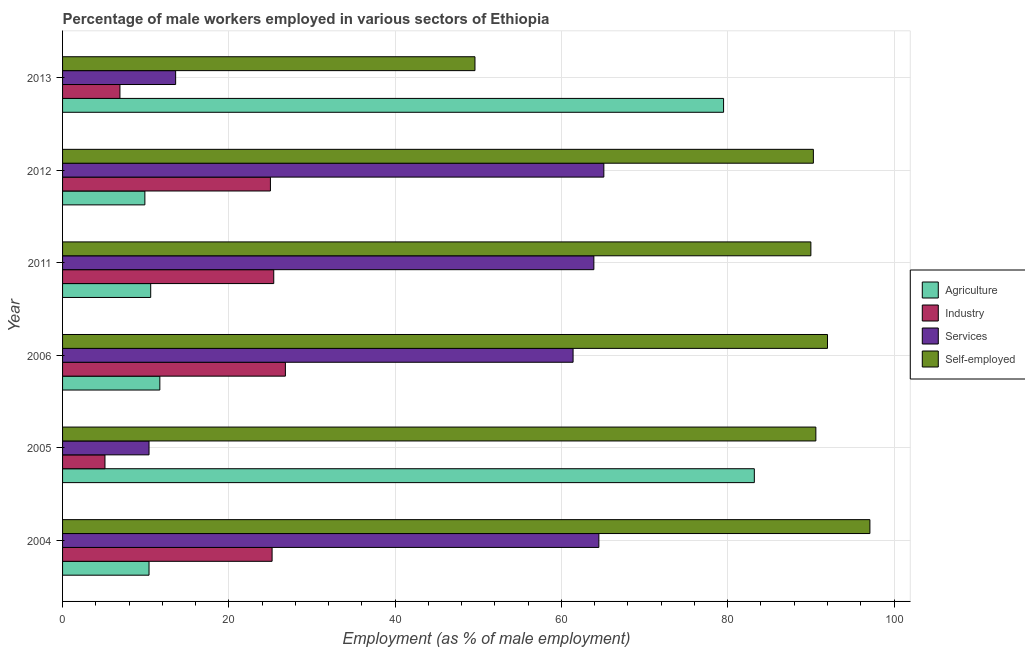How many different coloured bars are there?
Give a very brief answer. 4. Are the number of bars per tick equal to the number of legend labels?
Make the answer very short. Yes. Are the number of bars on each tick of the Y-axis equal?
Your answer should be very brief. Yes. How many bars are there on the 4th tick from the top?
Provide a short and direct response. 4. What is the label of the 1st group of bars from the top?
Keep it short and to the point. 2013. What is the percentage of male workers in services in 2013?
Make the answer very short. 13.6. Across all years, what is the maximum percentage of male workers in services?
Offer a very short reply. 65.1. Across all years, what is the minimum percentage of self employed male workers?
Offer a very short reply. 49.6. What is the total percentage of male workers in industry in the graph?
Give a very brief answer. 114.4. What is the difference between the percentage of male workers in services in 2005 and that in 2011?
Offer a very short reply. -53.5. What is the difference between the percentage of self employed male workers in 2013 and the percentage of male workers in agriculture in 2006?
Your response must be concise. 37.9. What is the average percentage of male workers in services per year?
Your answer should be compact. 46.48. In the year 2005, what is the difference between the percentage of male workers in industry and percentage of male workers in services?
Ensure brevity in your answer.  -5.3. In how many years, is the percentage of self employed male workers greater than 32 %?
Provide a succinct answer. 6. What is the ratio of the percentage of self employed male workers in 2004 to that in 2006?
Provide a short and direct response. 1.05. Is the percentage of self employed male workers in 2004 less than that in 2013?
Give a very brief answer. No. What is the difference between the highest and the second highest percentage of male workers in industry?
Make the answer very short. 1.4. What is the difference between the highest and the lowest percentage of self employed male workers?
Your answer should be very brief. 47.5. In how many years, is the percentage of self employed male workers greater than the average percentage of self employed male workers taken over all years?
Keep it short and to the point. 5. Is it the case that in every year, the sum of the percentage of self employed male workers and percentage of male workers in industry is greater than the sum of percentage of male workers in services and percentage of male workers in agriculture?
Provide a short and direct response. No. What does the 3rd bar from the top in 2005 represents?
Your response must be concise. Industry. What does the 1st bar from the bottom in 2012 represents?
Your response must be concise. Agriculture. How many years are there in the graph?
Make the answer very short. 6. What is the difference between two consecutive major ticks on the X-axis?
Provide a succinct answer. 20. How many legend labels are there?
Provide a succinct answer. 4. How are the legend labels stacked?
Ensure brevity in your answer.  Vertical. What is the title of the graph?
Give a very brief answer. Percentage of male workers employed in various sectors of Ethiopia. What is the label or title of the X-axis?
Give a very brief answer. Employment (as % of male employment). What is the label or title of the Y-axis?
Your answer should be very brief. Year. What is the Employment (as % of male employment) of Agriculture in 2004?
Keep it short and to the point. 10.4. What is the Employment (as % of male employment) of Industry in 2004?
Offer a terse response. 25.2. What is the Employment (as % of male employment) of Services in 2004?
Your answer should be very brief. 64.5. What is the Employment (as % of male employment) in Self-employed in 2004?
Provide a short and direct response. 97.1. What is the Employment (as % of male employment) in Agriculture in 2005?
Provide a short and direct response. 83.2. What is the Employment (as % of male employment) in Industry in 2005?
Your answer should be very brief. 5.1. What is the Employment (as % of male employment) of Services in 2005?
Provide a succinct answer. 10.4. What is the Employment (as % of male employment) of Self-employed in 2005?
Your response must be concise. 90.6. What is the Employment (as % of male employment) of Agriculture in 2006?
Make the answer very short. 11.7. What is the Employment (as % of male employment) in Industry in 2006?
Your answer should be compact. 26.8. What is the Employment (as % of male employment) in Services in 2006?
Keep it short and to the point. 61.4. What is the Employment (as % of male employment) in Self-employed in 2006?
Provide a succinct answer. 92. What is the Employment (as % of male employment) in Agriculture in 2011?
Offer a terse response. 10.6. What is the Employment (as % of male employment) in Industry in 2011?
Provide a succinct answer. 25.4. What is the Employment (as % of male employment) in Services in 2011?
Make the answer very short. 63.9. What is the Employment (as % of male employment) in Agriculture in 2012?
Offer a very short reply. 9.9. What is the Employment (as % of male employment) in Services in 2012?
Provide a succinct answer. 65.1. What is the Employment (as % of male employment) of Self-employed in 2012?
Offer a terse response. 90.3. What is the Employment (as % of male employment) in Agriculture in 2013?
Offer a terse response. 79.5. What is the Employment (as % of male employment) of Industry in 2013?
Provide a short and direct response. 6.9. What is the Employment (as % of male employment) in Services in 2013?
Give a very brief answer. 13.6. What is the Employment (as % of male employment) in Self-employed in 2013?
Keep it short and to the point. 49.6. Across all years, what is the maximum Employment (as % of male employment) in Agriculture?
Give a very brief answer. 83.2. Across all years, what is the maximum Employment (as % of male employment) in Industry?
Your answer should be compact. 26.8. Across all years, what is the maximum Employment (as % of male employment) of Services?
Offer a terse response. 65.1. Across all years, what is the maximum Employment (as % of male employment) of Self-employed?
Provide a short and direct response. 97.1. Across all years, what is the minimum Employment (as % of male employment) in Agriculture?
Give a very brief answer. 9.9. Across all years, what is the minimum Employment (as % of male employment) of Industry?
Give a very brief answer. 5.1. Across all years, what is the minimum Employment (as % of male employment) in Services?
Keep it short and to the point. 10.4. Across all years, what is the minimum Employment (as % of male employment) of Self-employed?
Provide a succinct answer. 49.6. What is the total Employment (as % of male employment) in Agriculture in the graph?
Give a very brief answer. 205.3. What is the total Employment (as % of male employment) in Industry in the graph?
Your response must be concise. 114.4. What is the total Employment (as % of male employment) of Services in the graph?
Provide a succinct answer. 278.9. What is the total Employment (as % of male employment) in Self-employed in the graph?
Offer a terse response. 509.6. What is the difference between the Employment (as % of male employment) of Agriculture in 2004 and that in 2005?
Give a very brief answer. -72.8. What is the difference between the Employment (as % of male employment) of Industry in 2004 and that in 2005?
Your response must be concise. 20.1. What is the difference between the Employment (as % of male employment) of Services in 2004 and that in 2005?
Your answer should be very brief. 54.1. What is the difference between the Employment (as % of male employment) of Industry in 2004 and that in 2006?
Offer a terse response. -1.6. What is the difference between the Employment (as % of male employment) of Services in 2004 and that in 2006?
Your response must be concise. 3.1. What is the difference between the Employment (as % of male employment) of Industry in 2004 and that in 2011?
Your answer should be compact. -0.2. What is the difference between the Employment (as % of male employment) in Services in 2004 and that in 2011?
Ensure brevity in your answer.  0.6. What is the difference between the Employment (as % of male employment) in Agriculture in 2004 and that in 2012?
Your answer should be compact. 0.5. What is the difference between the Employment (as % of male employment) of Services in 2004 and that in 2012?
Provide a succinct answer. -0.6. What is the difference between the Employment (as % of male employment) in Agriculture in 2004 and that in 2013?
Make the answer very short. -69.1. What is the difference between the Employment (as % of male employment) in Services in 2004 and that in 2013?
Your answer should be very brief. 50.9. What is the difference between the Employment (as % of male employment) of Self-employed in 2004 and that in 2013?
Give a very brief answer. 47.5. What is the difference between the Employment (as % of male employment) in Agriculture in 2005 and that in 2006?
Your answer should be very brief. 71.5. What is the difference between the Employment (as % of male employment) in Industry in 2005 and that in 2006?
Make the answer very short. -21.7. What is the difference between the Employment (as % of male employment) of Services in 2005 and that in 2006?
Offer a terse response. -51. What is the difference between the Employment (as % of male employment) of Agriculture in 2005 and that in 2011?
Offer a very short reply. 72.6. What is the difference between the Employment (as % of male employment) in Industry in 2005 and that in 2011?
Your answer should be very brief. -20.3. What is the difference between the Employment (as % of male employment) in Services in 2005 and that in 2011?
Ensure brevity in your answer.  -53.5. What is the difference between the Employment (as % of male employment) of Agriculture in 2005 and that in 2012?
Your response must be concise. 73.3. What is the difference between the Employment (as % of male employment) in Industry in 2005 and that in 2012?
Offer a terse response. -19.9. What is the difference between the Employment (as % of male employment) of Services in 2005 and that in 2012?
Keep it short and to the point. -54.7. What is the difference between the Employment (as % of male employment) of Agriculture in 2005 and that in 2013?
Your response must be concise. 3.7. What is the difference between the Employment (as % of male employment) of Industry in 2005 and that in 2013?
Your answer should be compact. -1.8. What is the difference between the Employment (as % of male employment) in Self-employed in 2005 and that in 2013?
Offer a very short reply. 41. What is the difference between the Employment (as % of male employment) of Services in 2006 and that in 2011?
Your answer should be compact. -2.5. What is the difference between the Employment (as % of male employment) in Self-employed in 2006 and that in 2011?
Provide a succinct answer. 2. What is the difference between the Employment (as % of male employment) in Services in 2006 and that in 2012?
Keep it short and to the point. -3.7. What is the difference between the Employment (as % of male employment) in Self-employed in 2006 and that in 2012?
Offer a very short reply. 1.7. What is the difference between the Employment (as % of male employment) in Agriculture in 2006 and that in 2013?
Your response must be concise. -67.8. What is the difference between the Employment (as % of male employment) of Services in 2006 and that in 2013?
Offer a terse response. 47.8. What is the difference between the Employment (as % of male employment) of Self-employed in 2006 and that in 2013?
Give a very brief answer. 42.4. What is the difference between the Employment (as % of male employment) in Agriculture in 2011 and that in 2013?
Your response must be concise. -68.9. What is the difference between the Employment (as % of male employment) of Services in 2011 and that in 2013?
Offer a terse response. 50.3. What is the difference between the Employment (as % of male employment) in Self-employed in 2011 and that in 2013?
Provide a succinct answer. 40.4. What is the difference between the Employment (as % of male employment) of Agriculture in 2012 and that in 2013?
Offer a terse response. -69.6. What is the difference between the Employment (as % of male employment) in Industry in 2012 and that in 2013?
Give a very brief answer. 18.1. What is the difference between the Employment (as % of male employment) of Services in 2012 and that in 2013?
Provide a succinct answer. 51.5. What is the difference between the Employment (as % of male employment) in Self-employed in 2012 and that in 2013?
Make the answer very short. 40.7. What is the difference between the Employment (as % of male employment) in Agriculture in 2004 and the Employment (as % of male employment) in Self-employed in 2005?
Provide a succinct answer. -80.2. What is the difference between the Employment (as % of male employment) of Industry in 2004 and the Employment (as % of male employment) of Self-employed in 2005?
Your answer should be compact. -65.4. What is the difference between the Employment (as % of male employment) in Services in 2004 and the Employment (as % of male employment) in Self-employed in 2005?
Provide a short and direct response. -26.1. What is the difference between the Employment (as % of male employment) of Agriculture in 2004 and the Employment (as % of male employment) of Industry in 2006?
Ensure brevity in your answer.  -16.4. What is the difference between the Employment (as % of male employment) of Agriculture in 2004 and the Employment (as % of male employment) of Services in 2006?
Your answer should be very brief. -51. What is the difference between the Employment (as % of male employment) of Agriculture in 2004 and the Employment (as % of male employment) of Self-employed in 2006?
Give a very brief answer. -81.6. What is the difference between the Employment (as % of male employment) of Industry in 2004 and the Employment (as % of male employment) of Services in 2006?
Your response must be concise. -36.2. What is the difference between the Employment (as % of male employment) of Industry in 2004 and the Employment (as % of male employment) of Self-employed in 2006?
Keep it short and to the point. -66.8. What is the difference between the Employment (as % of male employment) in Services in 2004 and the Employment (as % of male employment) in Self-employed in 2006?
Offer a very short reply. -27.5. What is the difference between the Employment (as % of male employment) in Agriculture in 2004 and the Employment (as % of male employment) in Services in 2011?
Give a very brief answer. -53.5. What is the difference between the Employment (as % of male employment) in Agriculture in 2004 and the Employment (as % of male employment) in Self-employed in 2011?
Keep it short and to the point. -79.6. What is the difference between the Employment (as % of male employment) in Industry in 2004 and the Employment (as % of male employment) in Services in 2011?
Provide a succinct answer. -38.7. What is the difference between the Employment (as % of male employment) in Industry in 2004 and the Employment (as % of male employment) in Self-employed in 2011?
Ensure brevity in your answer.  -64.8. What is the difference between the Employment (as % of male employment) of Services in 2004 and the Employment (as % of male employment) of Self-employed in 2011?
Offer a terse response. -25.5. What is the difference between the Employment (as % of male employment) in Agriculture in 2004 and the Employment (as % of male employment) in Industry in 2012?
Offer a very short reply. -14.6. What is the difference between the Employment (as % of male employment) in Agriculture in 2004 and the Employment (as % of male employment) in Services in 2012?
Give a very brief answer. -54.7. What is the difference between the Employment (as % of male employment) of Agriculture in 2004 and the Employment (as % of male employment) of Self-employed in 2012?
Keep it short and to the point. -79.9. What is the difference between the Employment (as % of male employment) in Industry in 2004 and the Employment (as % of male employment) in Services in 2012?
Your response must be concise. -39.9. What is the difference between the Employment (as % of male employment) in Industry in 2004 and the Employment (as % of male employment) in Self-employed in 2012?
Provide a short and direct response. -65.1. What is the difference between the Employment (as % of male employment) of Services in 2004 and the Employment (as % of male employment) of Self-employed in 2012?
Ensure brevity in your answer.  -25.8. What is the difference between the Employment (as % of male employment) of Agriculture in 2004 and the Employment (as % of male employment) of Industry in 2013?
Keep it short and to the point. 3.5. What is the difference between the Employment (as % of male employment) of Agriculture in 2004 and the Employment (as % of male employment) of Self-employed in 2013?
Offer a terse response. -39.2. What is the difference between the Employment (as % of male employment) of Industry in 2004 and the Employment (as % of male employment) of Services in 2013?
Give a very brief answer. 11.6. What is the difference between the Employment (as % of male employment) in Industry in 2004 and the Employment (as % of male employment) in Self-employed in 2013?
Provide a short and direct response. -24.4. What is the difference between the Employment (as % of male employment) in Services in 2004 and the Employment (as % of male employment) in Self-employed in 2013?
Your answer should be very brief. 14.9. What is the difference between the Employment (as % of male employment) of Agriculture in 2005 and the Employment (as % of male employment) of Industry in 2006?
Your response must be concise. 56.4. What is the difference between the Employment (as % of male employment) of Agriculture in 2005 and the Employment (as % of male employment) of Services in 2006?
Provide a short and direct response. 21.8. What is the difference between the Employment (as % of male employment) of Industry in 2005 and the Employment (as % of male employment) of Services in 2006?
Provide a succinct answer. -56.3. What is the difference between the Employment (as % of male employment) in Industry in 2005 and the Employment (as % of male employment) in Self-employed in 2006?
Your response must be concise. -86.9. What is the difference between the Employment (as % of male employment) of Services in 2005 and the Employment (as % of male employment) of Self-employed in 2006?
Offer a terse response. -81.6. What is the difference between the Employment (as % of male employment) of Agriculture in 2005 and the Employment (as % of male employment) of Industry in 2011?
Ensure brevity in your answer.  57.8. What is the difference between the Employment (as % of male employment) in Agriculture in 2005 and the Employment (as % of male employment) in Services in 2011?
Offer a terse response. 19.3. What is the difference between the Employment (as % of male employment) of Industry in 2005 and the Employment (as % of male employment) of Services in 2011?
Give a very brief answer. -58.8. What is the difference between the Employment (as % of male employment) in Industry in 2005 and the Employment (as % of male employment) in Self-employed in 2011?
Your response must be concise. -84.9. What is the difference between the Employment (as % of male employment) in Services in 2005 and the Employment (as % of male employment) in Self-employed in 2011?
Offer a very short reply. -79.6. What is the difference between the Employment (as % of male employment) of Agriculture in 2005 and the Employment (as % of male employment) of Industry in 2012?
Make the answer very short. 58.2. What is the difference between the Employment (as % of male employment) of Agriculture in 2005 and the Employment (as % of male employment) of Services in 2012?
Give a very brief answer. 18.1. What is the difference between the Employment (as % of male employment) of Industry in 2005 and the Employment (as % of male employment) of Services in 2012?
Ensure brevity in your answer.  -60. What is the difference between the Employment (as % of male employment) in Industry in 2005 and the Employment (as % of male employment) in Self-employed in 2012?
Your answer should be very brief. -85.2. What is the difference between the Employment (as % of male employment) in Services in 2005 and the Employment (as % of male employment) in Self-employed in 2012?
Give a very brief answer. -79.9. What is the difference between the Employment (as % of male employment) in Agriculture in 2005 and the Employment (as % of male employment) in Industry in 2013?
Provide a succinct answer. 76.3. What is the difference between the Employment (as % of male employment) of Agriculture in 2005 and the Employment (as % of male employment) of Services in 2013?
Give a very brief answer. 69.6. What is the difference between the Employment (as % of male employment) of Agriculture in 2005 and the Employment (as % of male employment) of Self-employed in 2013?
Offer a very short reply. 33.6. What is the difference between the Employment (as % of male employment) of Industry in 2005 and the Employment (as % of male employment) of Services in 2013?
Provide a succinct answer. -8.5. What is the difference between the Employment (as % of male employment) of Industry in 2005 and the Employment (as % of male employment) of Self-employed in 2013?
Provide a succinct answer. -44.5. What is the difference between the Employment (as % of male employment) of Services in 2005 and the Employment (as % of male employment) of Self-employed in 2013?
Your answer should be very brief. -39.2. What is the difference between the Employment (as % of male employment) of Agriculture in 2006 and the Employment (as % of male employment) of Industry in 2011?
Your answer should be compact. -13.7. What is the difference between the Employment (as % of male employment) of Agriculture in 2006 and the Employment (as % of male employment) of Services in 2011?
Give a very brief answer. -52.2. What is the difference between the Employment (as % of male employment) of Agriculture in 2006 and the Employment (as % of male employment) of Self-employed in 2011?
Offer a very short reply. -78.3. What is the difference between the Employment (as % of male employment) of Industry in 2006 and the Employment (as % of male employment) of Services in 2011?
Make the answer very short. -37.1. What is the difference between the Employment (as % of male employment) of Industry in 2006 and the Employment (as % of male employment) of Self-employed in 2011?
Offer a terse response. -63.2. What is the difference between the Employment (as % of male employment) in Services in 2006 and the Employment (as % of male employment) in Self-employed in 2011?
Keep it short and to the point. -28.6. What is the difference between the Employment (as % of male employment) of Agriculture in 2006 and the Employment (as % of male employment) of Industry in 2012?
Ensure brevity in your answer.  -13.3. What is the difference between the Employment (as % of male employment) of Agriculture in 2006 and the Employment (as % of male employment) of Services in 2012?
Provide a short and direct response. -53.4. What is the difference between the Employment (as % of male employment) in Agriculture in 2006 and the Employment (as % of male employment) in Self-employed in 2012?
Offer a very short reply. -78.6. What is the difference between the Employment (as % of male employment) in Industry in 2006 and the Employment (as % of male employment) in Services in 2012?
Offer a very short reply. -38.3. What is the difference between the Employment (as % of male employment) in Industry in 2006 and the Employment (as % of male employment) in Self-employed in 2012?
Ensure brevity in your answer.  -63.5. What is the difference between the Employment (as % of male employment) of Services in 2006 and the Employment (as % of male employment) of Self-employed in 2012?
Your response must be concise. -28.9. What is the difference between the Employment (as % of male employment) in Agriculture in 2006 and the Employment (as % of male employment) in Industry in 2013?
Offer a very short reply. 4.8. What is the difference between the Employment (as % of male employment) of Agriculture in 2006 and the Employment (as % of male employment) of Self-employed in 2013?
Provide a succinct answer. -37.9. What is the difference between the Employment (as % of male employment) in Industry in 2006 and the Employment (as % of male employment) in Self-employed in 2013?
Your response must be concise. -22.8. What is the difference between the Employment (as % of male employment) of Services in 2006 and the Employment (as % of male employment) of Self-employed in 2013?
Provide a short and direct response. 11.8. What is the difference between the Employment (as % of male employment) of Agriculture in 2011 and the Employment (as % of male employment) of Industry in 2012?
Make the answer very short. -14.4. What is the difference between the Employment (as % of male employment) of Agriculture in 2011 and the Employment (as % of male employment) of Services in 2012?
Your response must be concise. -54.5. What is the difference between the Employment (as % of male employment) of Agriculture in 2011 and the Employment (as % of male employment) of Self-employed in 2012?
Offer a very short reply. -79.7. What is the difference between the Employment (as % of male employment) in Industry in 2011 and the Employment (as % of male employment) in Services in 2012?
Your response must be concise. -39.7. What is the difference between the Employment (as % of male employment) of Industry in 2011 and the Employment (as % of male employment) of Self-employed in 2012?
Your answer should be compact. -64.9. What is the difference between the Employment (as % of male employment) of Services in 2011 and the Employment (as % of male employment) of Self-employed in 2012?
Your answer should be compact. -26.4. What is the difference between the Employment (as % of male employment) in Agriculture in 2011 and the Employment (as % of male employment) in Services in 2013?
Give a very brief answer. -3. What is the difference between the Employment (as % of male employment) of Agriculture in 2011 and the Employment (as % of male employment) of Self-employed in 2013?
Provide a succinct answer. -39. What is the difference between the Employment (as % of male employment) of Industry in 2011 and the Employment (as % of male employment) of Services in 2013?
Give a very brief answer. 11.8. What is the difference between the Employment (as % of male employment) in Industry in 2011 and the Employment (as % of male employment) in Self-employed in 2013?
Keep it short and to the point. -24.2. What is the difference between the Employment (as % of male employment) in Services in 2011 and the Employment (as % of male employment) in Self-employed in 2013?
Provide a succinct answer. 14.3. What is the difference between the Employment (as % of male employment) in Agriculture in 2012 and the Employment (as % of male employment) in Services in 2013?
Your answer should be compact. -3.7. What is the difference between the Employment (as % of male employment) in Agriculture in 2012 and the Employment (as % of male employment) in Self-employed in 2013?
Make the answer very short. -39.7. What is the difference between the Employment (as % of male employment) in Industry in 2012 and the Employment (as % of male employment) in Self-employed in 2013?
Give a very brief answer. -24.6. What is the average Employment (as % of male employment) of Agriculture per year?
Your response must be concise. 34.22. What is the average Employment (as % of male employment) of Industry per year?
Offer a terse response. 19.07. What is the average Employment (as % of male employment) of Services per year?
Provide a short and direct response. 46.48. What is the average Employment (as % of male employment) of Self-employed per year?
Ensure brevity in your answer.  84.93. In the year 2004, what is the difference between the Employment (as % of male employment) of Agriculture and Employment (as % of male employment) of Industry?
Ensure brevity in your answer.  -14.8. In the year 2004, what is the difference between the Employment (as % of male employment) of Agriculture and Employment (as % of male employment) of Services?
Provide a short and direct response. -54.1. In the year 2004, what is the difference between the Employment (as % of male employment) in Agriculture and Employment (as % of male employment) in Self-employed?
Provide a succinct answer. -86.7. In the year 2004, what is the difference between the Employment (as % of male employment) of Industry and Employment (as % of male employment) of Services?
Your answer should be very brief. -39.3. In the year 2004, what is the difference between the Employment (as % of male employment) of Industry and Employment (as % of male employment) of Self-employed?
Offer a terse response. -71.9. In the year 2004, what is the difference between the Employment (as % of male employment) of Services and Employment (as % of male employment) of Self-employed?
Keep it short and to the point. -32.6. In the year 2005, what is the difference between the Employment (as % of male employment) of Agriculture and Employment (as % of male employment) of Industry?
Provide a succinct answer. 78.1. In the year 2005, what is the difference between the Employment (as % of male employment) of Agriculture and Employment (as % of male employment) of Services?
Provide a short and direct response. 72.8. In the year 2005, what is the difference between the Employment (as % of male employment) in Agriculture and Employment (as % of male employment) in Self-employed?
Ensure brevity in your answer.  -7.4. In the year 2005, what is the difference between the Employment (as % of male employment) in Industry and Employment (as % of male employment) in Services?
Ensure brevity in your answer.  -5.3. In the year 2005, what is the difference between the Employment (as % of male employment) of Industry and Employment (as % of male employment) of Self-employed?
Offer a very short reply. -85.5. In the year 2005, what is the difference between the Employment (as % of male employment) of Services and Employment (as % of male employment) of Self-employed?
Ensure brevity in your answer.  -80.2. In the year 2006, what is the difference between the Employment (as % of male employment) in Agriculture and Employment (as % of male employment) in Industry?
Your response must be concise. -15.1. In the year 2006, what is the difference between the Employment (as % of male employment) in Agriculture and Employment (as % of male employment) in Services?
Your answer should be compact. -49.7. In the year 2006, what is the difference between the Employment (as % of male employment) in Agriculture and Employment (as % of male employment) in Self-employed?
Offer a very short reply. -80.3. In the year 2006, what is the difference between the Employment (as % of male employment) in Industry and Employment (as % of male employment) in Services?
Keep it short and to the point. -34.6. In the year 2006, what is the difference between the Employment (as % of male employment) of Industry and Employment (as % of male employment) of Self-employed?
Make the answer very short. -65.2. In the year 2006, what is the difference between the Employment (as % of male employment) of Services and Employment (as % of male employment) of Self-employed?
Your response must be concise. -30.6. In the year 2011, what is the difference between the Employment (as % of male employment) of Agriculture and Employment (as % of male employment) of Industry?
Your answer should be very brief. -14.8. In the year 2011, what is the difference between the Employment (as % of male employment) in Agriculture and Employment (as % of male employment) in Services?
Keep it short and to the point. -53.3. In the year 2011, what is the difference between the Employment (as % of male employment) of Agriculture and Employment (as % of male employment) of Self-employed?
Give a very brief answer. -79.4. In the year 2011, what is the difference between the Employment (as % of male employment) in Industry and Employment (as % of male employment) in Services?
Make the answer very short. -38.5. In the year 2011, what is the difference between the Employment (as % of male employment) in Industry and Employment (as % of male employment) in Self-employed?
Make the answer very short. -64.6. In the year 2011, what is the difference between the Employment (as % of male employment) of Services and Employment (as % of male employment) of Self-employed?
Your answer should be compact. -26.1. In the year 2012, what is the difference between the Employment (as % of male employment) of Agriculture and Employment (as % of male employment) of Industry?
Offer a very short reply. -15.1. In the year 2012, what is the difference between the Employment (as % of male employment) of Agriculture and Employment (as % of male employment) of Services?
Ensure brevity in your answer.  -55.2. In the year 2012, what is the difference between the Employment (as % of male employment) of Agriculture and Employment (as % of male employment) of Self-employed?
Keep it short and to the point. -80.4. In the year 2012, what is the difference between the Employment (as % of male employment) of Industry and Employment (as % of male employment) of Services?
Give a very brief answer. -40.1. In the year 2012, what is the difference between the Employment (as % of male employment) of Industry and Employment (as % of male employment) of Self-employed?
Offer a terse response. -65.3. In the year 2012, what is the difference between the Employment (as % of male employment) of Services and Employment (as % of male employment) of Self-employed?
Your answer should be very brief. -25.2. In the year 2013, what is the difference between the Employment (as % of male employment) of Agriculture and Employment (as % of male employment) of Industry?
Your response must be concise. 72.6. In the year 2013, what is the difference between the Employment (as % of male employment) in Agriculture and Employment (as % of male employment) in Services?
Your answer should be very brief. 65.9. In the year 2013, what is the difference between the Employment (as % of male employment) of Agriculture and Employment (as % of male employment) of Self-employed?
Your answer should be very brief. 29.9. In the year 2013, what is the difference between the Employment (as % of male employment) of Industry and Employment (as % of male employment) of Services?
Keep it short and to the point. -6.7. In the year 2013, what is the difference between the Employment (as % of male employment) in Industry and Employment (as % of male employment) in Self-employed?
Your response must be concise. -42.7. In the year 2013, what is the difference between the Employment (as % of male employment) in Services and Employment (as % of male employment) in Self-employed?
Your response must be concise. -36. What is the ratio of the Employment (as % of male employment) of Industry in 2004 to that in 2005?
Make the answer very short. 4.94. What is the ratio of the Employment (as % of male employment) in Services in 2004 to that in 2005?
Give a very brief answer. 6.2. What is the ratio of the Employment (as % of male employment) of Self-employed in 2004 to that in 2005?
Your response must be concise. 1.07. What is the ratio of the Employment (as % of male employment) of Agriculture in 2004 to that in 2006?
Your answer should be compact. 0.89. What is the ratio of the Employment (as % of male employment) in Industry in 2004 to that in 2006?
Your answer should be compact. 0.94. What is the ratio of the Employment (as % of male employment) in Services in 2004 to that in 2006?
Give a very brief answer. 1.05. What is the ratio of the Employment (as % of male employment) in Self-employed in 2004 to that in 2006?
Your response must be concise. 1.06. What is the ratio of the Employment (as % of male employment) of Agriculture in 2004 to that in 2011?
Make the answer very short. 0.98. What is the ratio of the Employment (as % of male employment) of Industry in 2004 to that in 2011?
Provide a succinct answer. 0.99. What is the ratio of the Employment (as % of male employment) of Services in 2004 to that in 2011?
Provide a succinct answer. 1.01. What is the ratio of the Employment (as % of male employment) of Self-employed in 2004 to that in 2011?
Ensure brevity in your answer.  1.08. What is the ratio of the Employment (as % of male employment) of Agriculture in 2004 to that in 2012?
Your answer should be compact. 1.05. What is the ratio of the Employment (as % of male employment) of Industry in 2004 to that in 2012?
Provide a succinct answer. 1.01. What is the ratio of the Employment (as % of male employment) of Self-employed in 2004 to that in 2012?
Your answer should be very brief. 1.08. What is the ratio of the Employment (as % of male employment) of Agriculture in 2004 to that in 2013?
Offer a very short reply. 0.13. What is the ratio of the Employment (as % of male employment) in Industry in 2004 to that in 2013?
Your response must be concise. 3.65. What is the ratio of the Employment (as % of male employment) of Services in 2004 to that in 2013?
Make the answer very short. 4.74. What is the ratio of the Employment (as % of male employment) of Self-employed in 2004 to that in 2013?
Give a very brief answer. 1.96. What is the ratio of the Employment (as % of male employment) in Agriculture in 2005 to that in 2006?
Your answer should be compact. 7.11. What is the ratio of the Employment (as % of male employment) in Industry in 2005 to that in 2006?
Make the answer very short. 0.19. What is the ratio of the Employment (as % of male employment) of Services in 2005 to that in 2006?
Provide a succinct answer. 0.17. What is the ratio of the Employment (as % of male employment) of Self-employed in 2005 to that in 2006?
Your answer should be compact. 0.98. What is the ratio of the Employment (as % of male employment) in Agriculture in 2005 to that in 2011?
Your answer should be compact. 7.85. What is the ratio of the Employment (as % of male employment) of Industry in 2005 to that in 2011?
Offer a very short reply. 0.2. What is the ratio of the Employment (as % of male employment) in Services in 2005 to that in 2011?
Keep it short and to the point. 0.16. What is the ratio of the Employment (as % of male employment) in Agriculture in 2005 to that in 2012?
Offer a very short reply. 8.4. What is the ratio of the Employment (as % of male employment) in Industry in 2005 to that in 2012?
Give a very brief answer. 0.2. What is the ratio of the Employment (as % of male employment) in Services in 2005 to that in 2012?
Give a very brief answer. 0.16. What is the ratio of the Employment (as % of male employment) of Agriculture in 2005 to that in 2013?
Offer a very short reply. 1.05. What is the ratio of the Employment (as % of male employment) in Industry in 2005 to that in 2013?
Give a very brief answer. 0.74. What is the ratio of the Employment (as % of male employment) in Services in 2005 to that in 2013?
Offer a very short reply. 0.76. What is the ratio of the Employment (as % of male employment) in Self-employed in 2005 to that in 2013?
Make the answer very short. 1.83. What is the ratio of the Employment (as % of male employment) of Agriculture in 2006 to that in 2011?
Your response must be concise. 1.1. What is the ratio of the Employment (as % of male employment) in Industry in 2006 to that in 2011?
Your answer should be compact. 1.06. What is the ratio of the Employment (as % of male employment) of Services in 2006 to that in 2011?
Your answer should be very brief. 0.96. What is the ratio of the Employment (as % of male employment) of Self-employed in 2006 to that in 2011?
Ensure brevity in your answer.  1.02. What is the ratio of the Employment (as % of male employment) in Agriculture in 2006 to that in 2012?
Offer a very short reply. 1.18. What is the ratio of the Employment (as % of male employment) of Industry in 2006 to that in 2012?
Your answer should be very brief. 1.07. What is the ratio of the Employment (as % of male employment) of Services in 2006 to that in 2012?
Your answer should be compact. 0.94. What is the ratio of the Employment (as % of male employment) of Self-employed in 2006 to that in 2012?
Offer a terse response. 1.02. What is the ratio of the Employment (as % of male employment) in Agriculture in 2006 to that in 2013?
Your answer should be compact. 0.15. What is the ratio of the Employment (as % of male employment) of Industry in 2006 to that in 2013?
Your response must be concise. 3.88. What is the ratio of the Employment (as % of male employment) of Services in 2006 to that in 2013?
Make the answer very short. 4.51. What is the ratio of the Employment (as % of male employment) of Self-employed in 2006 to that in 2013?
Offer a very short reply. 1.85. What is the ratio of the Employment (as % of male employment) in Agriculture in 2011 to that in 2012?
Give a very brief answer. 1.07. What is the ratio of the Employment (as % of male employment) in Services in 2011 to that in 2012?
Provide a short and direct response. 0.98. What is the ratio of the Employment (as % of male employment) in Agriculture in 2011 to that in 2013?
Provide a succinct answer. 0.13. What is the ratio of the Employment (as % of male employment) in Industry in 2011 to that in 2013?
Provide a short and direct response. 3.68. What is the ratio of the Employment (as % of male employment) of Services in 2011 to that in 2013?
Your answer should be very brief. 4.7. What is the ratio of the Employment (as % of male employment) of Self-employed in 2011 to that in 2013?
Provide a short and direct response. 1.81. What is the ratio of the Employment (as % of male employment) of Agriculture in 2012 to that in 2013?
Ensure brevity in your answer.  0.12. What is the ratio of the Employment (as % of male employment) of Industry in 2012 to that in 2013?
Your response must be concise. 3.62. What is the ratio of the Employment (as % of male employment) in Services in 2012 to that in 2013?
Provide a succinct answer. 4.79. What is the ratio of the Employment (as % of male employment) of Self-employed in 2012 to that in 2013?
Your answer should be compact. 1.82. What is the difference between the highest and the second highest Employment (as % of male employment) of Industry?
Your response must be concise. 1.4. What is the difference between the highest and the lowest Employment (as % of male employment) of Agriculture?
Provide a succinct answer. 73.3. What is the difference between the highest and the lowest Employment (as % of male employment) in Industry?
Offer a terse response. 21.7. What is the difference between the highest and the lowest Employment (as % of male employment) of Services?
Offer a very short reply. 54.7. What is the difference between the highest and the lowest Employment (as % of male employment) in Self-employed?
Offer a very short reply. 47.5. 